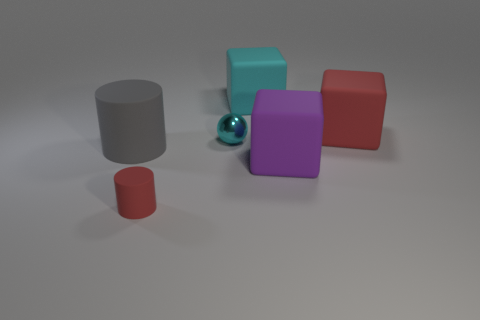How many objects are there in total? In total, there are six objects present in the image. 